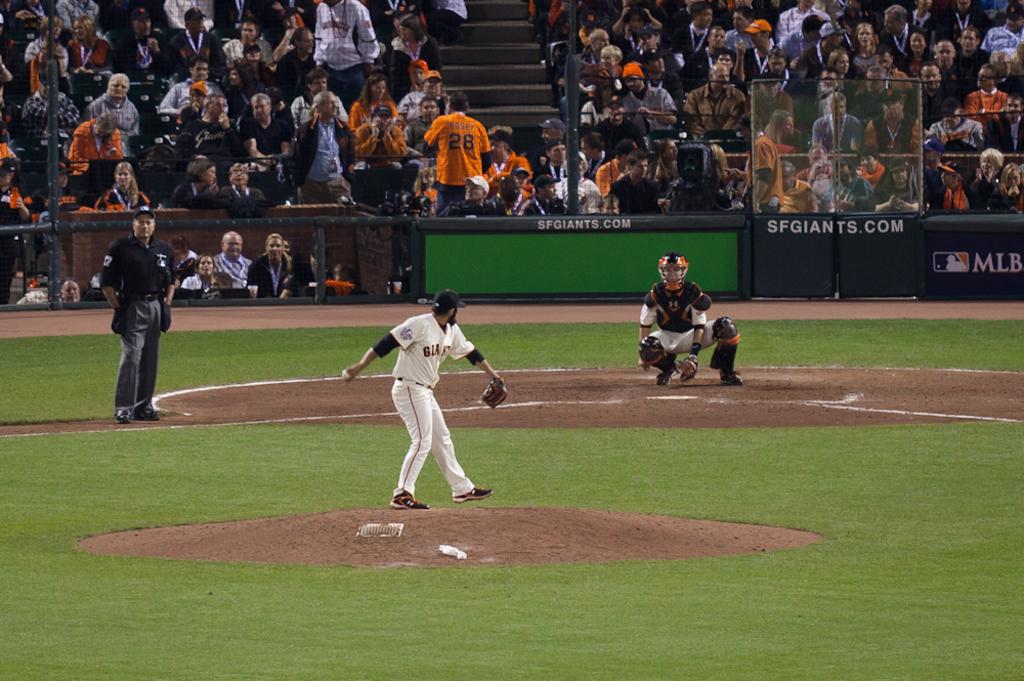<image>
Present a compact description of the photo's key features. Fans watch as the Giants pitcher is about to throw the baseball to the catcher. 